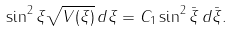Convert formula to latex. <formula><loc_0><loc_0><loc_500><loc_500>\sin ^ { 2 } \xi \sqrt { V ( \xi ) } \, d \xi = C _ { 1 } \sin ^ { 2 } \bar { \xi } \, d \bar { \xi } .</formula> 